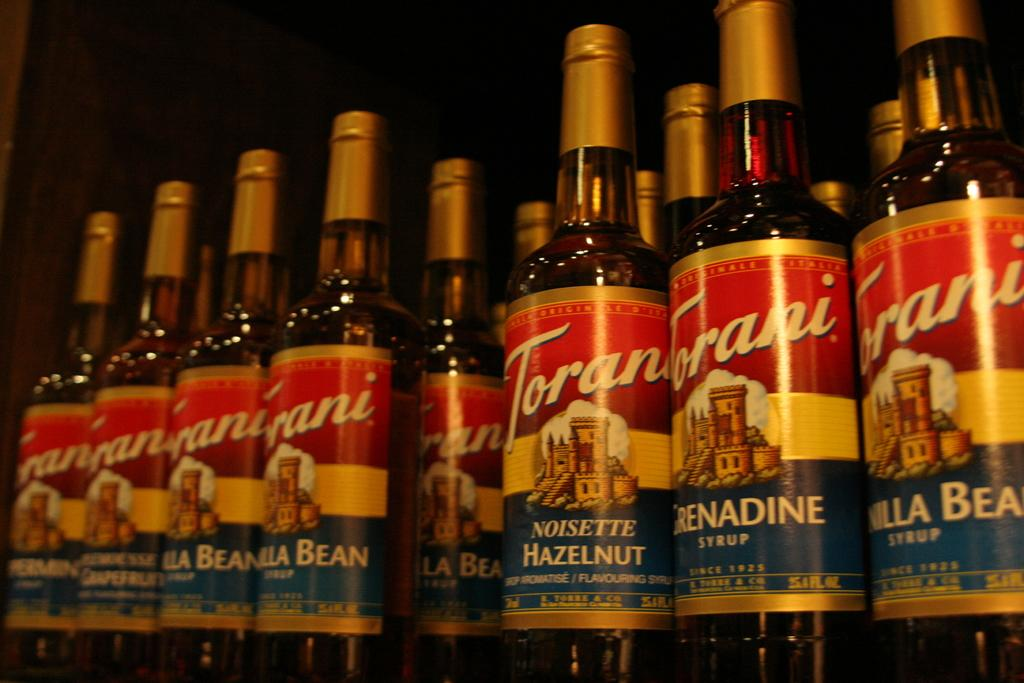What objects are present in the image? There are multiple bottles in the image. What feature do all the bottles have in common? Each bottle has a cap. Are there any additional decorations or markings on the bottles? Yes, each bottle has a sticker. What type of jewel can be seen embedded in the stone in the image? There is no jewel or stone present in the image; it only features bottles with caps and stickers. 